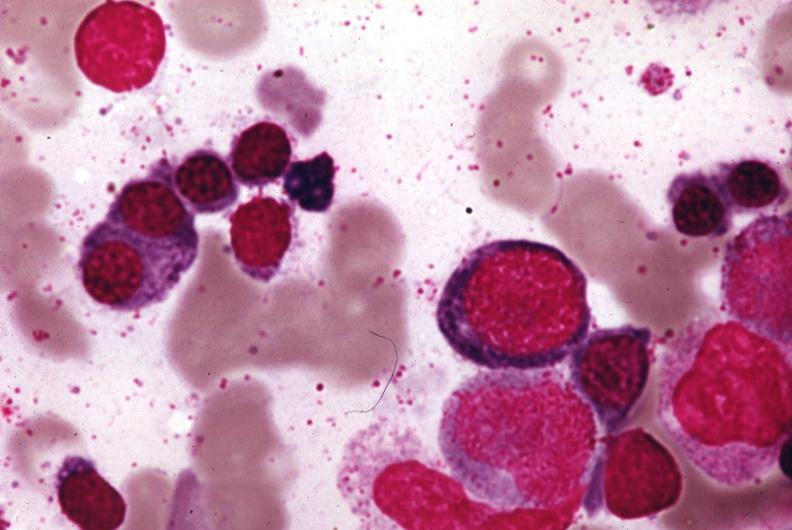s atheromatous embolus present?
Answer the question using a single word or phrase. No 